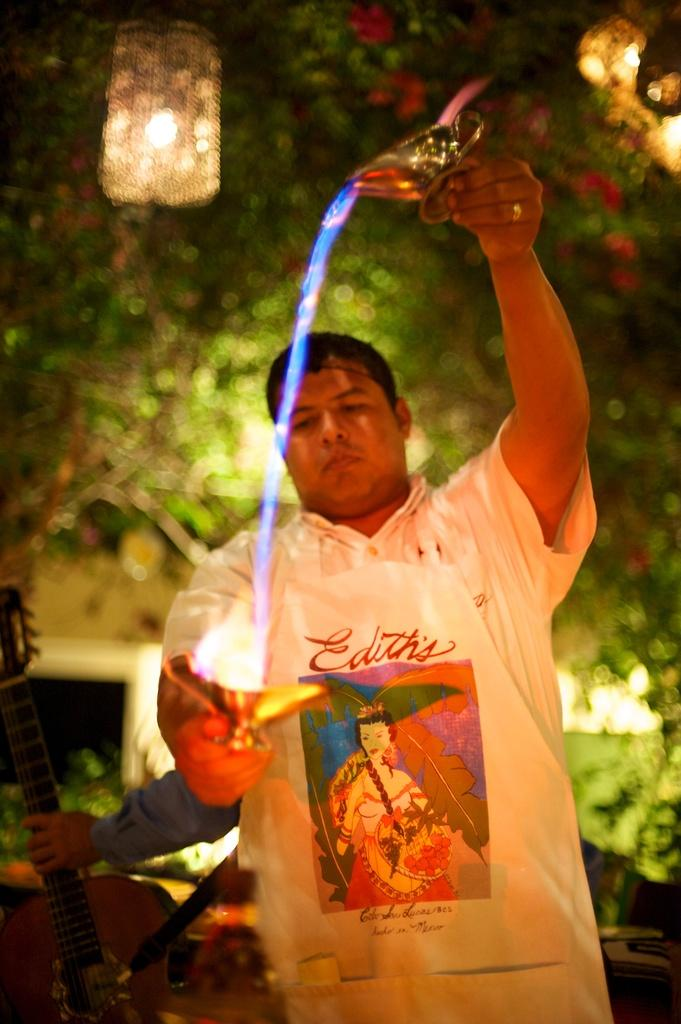What is the person in the image doing with the objects? The person is holding objects in the image. Can you describe the hand of the person in the image? There is a hand of a person holding an object in the image. What type of natural element can be seen in the image? There is a tree visible in the image. What type of lighting is present at the top of the image? There are two lights at the top of the image. What type of apple is being judged for destruction in the image? There is no apple, judge, or destruction present in the image. 